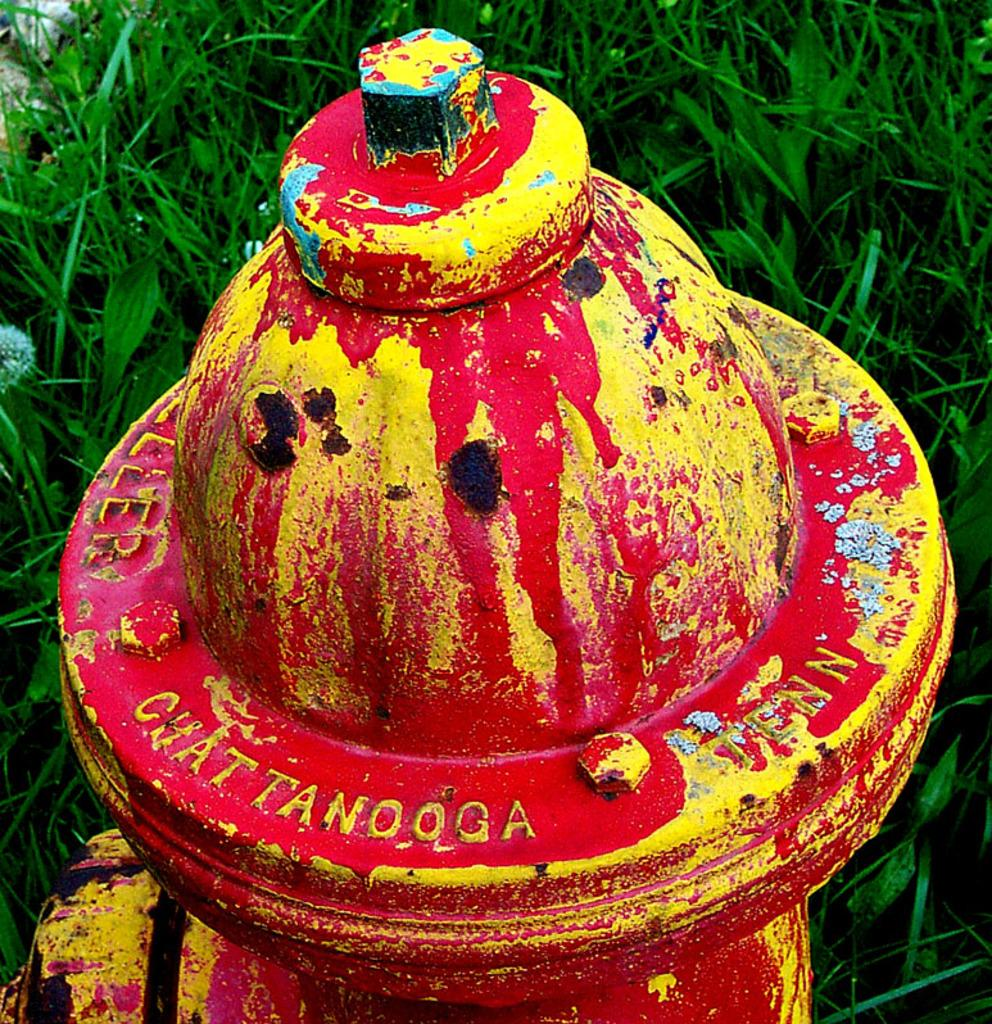What type of object is in the image? There is a metal dome-like object in the image. What are the characteristics of the object? The object has nuts and bolts, and there is text embossed on it. What colors are used for the text on the object? The text is painted in red and yellow. Where is the object located in the image? The object is on the ground. What can be seen in the background of the image? There is grass visible behind the object. How much honey is stored in the metal dome-like object in the image? There is no honey stored in the metal dome-like object in the image. How many beds are visible in the image? There are no beds visible in the image. 